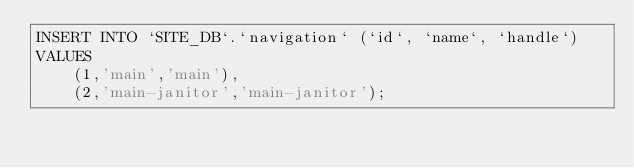<code> <loc_0><loc_0><loc_500><loc_500><_SQL_>INSERT INTO `SITE_DB`.`navigation` (`id`, `name`, `handle`)
VALUES
	(1,'main','main'),
	(2,'main-janitor','main-janitor');
</code> 